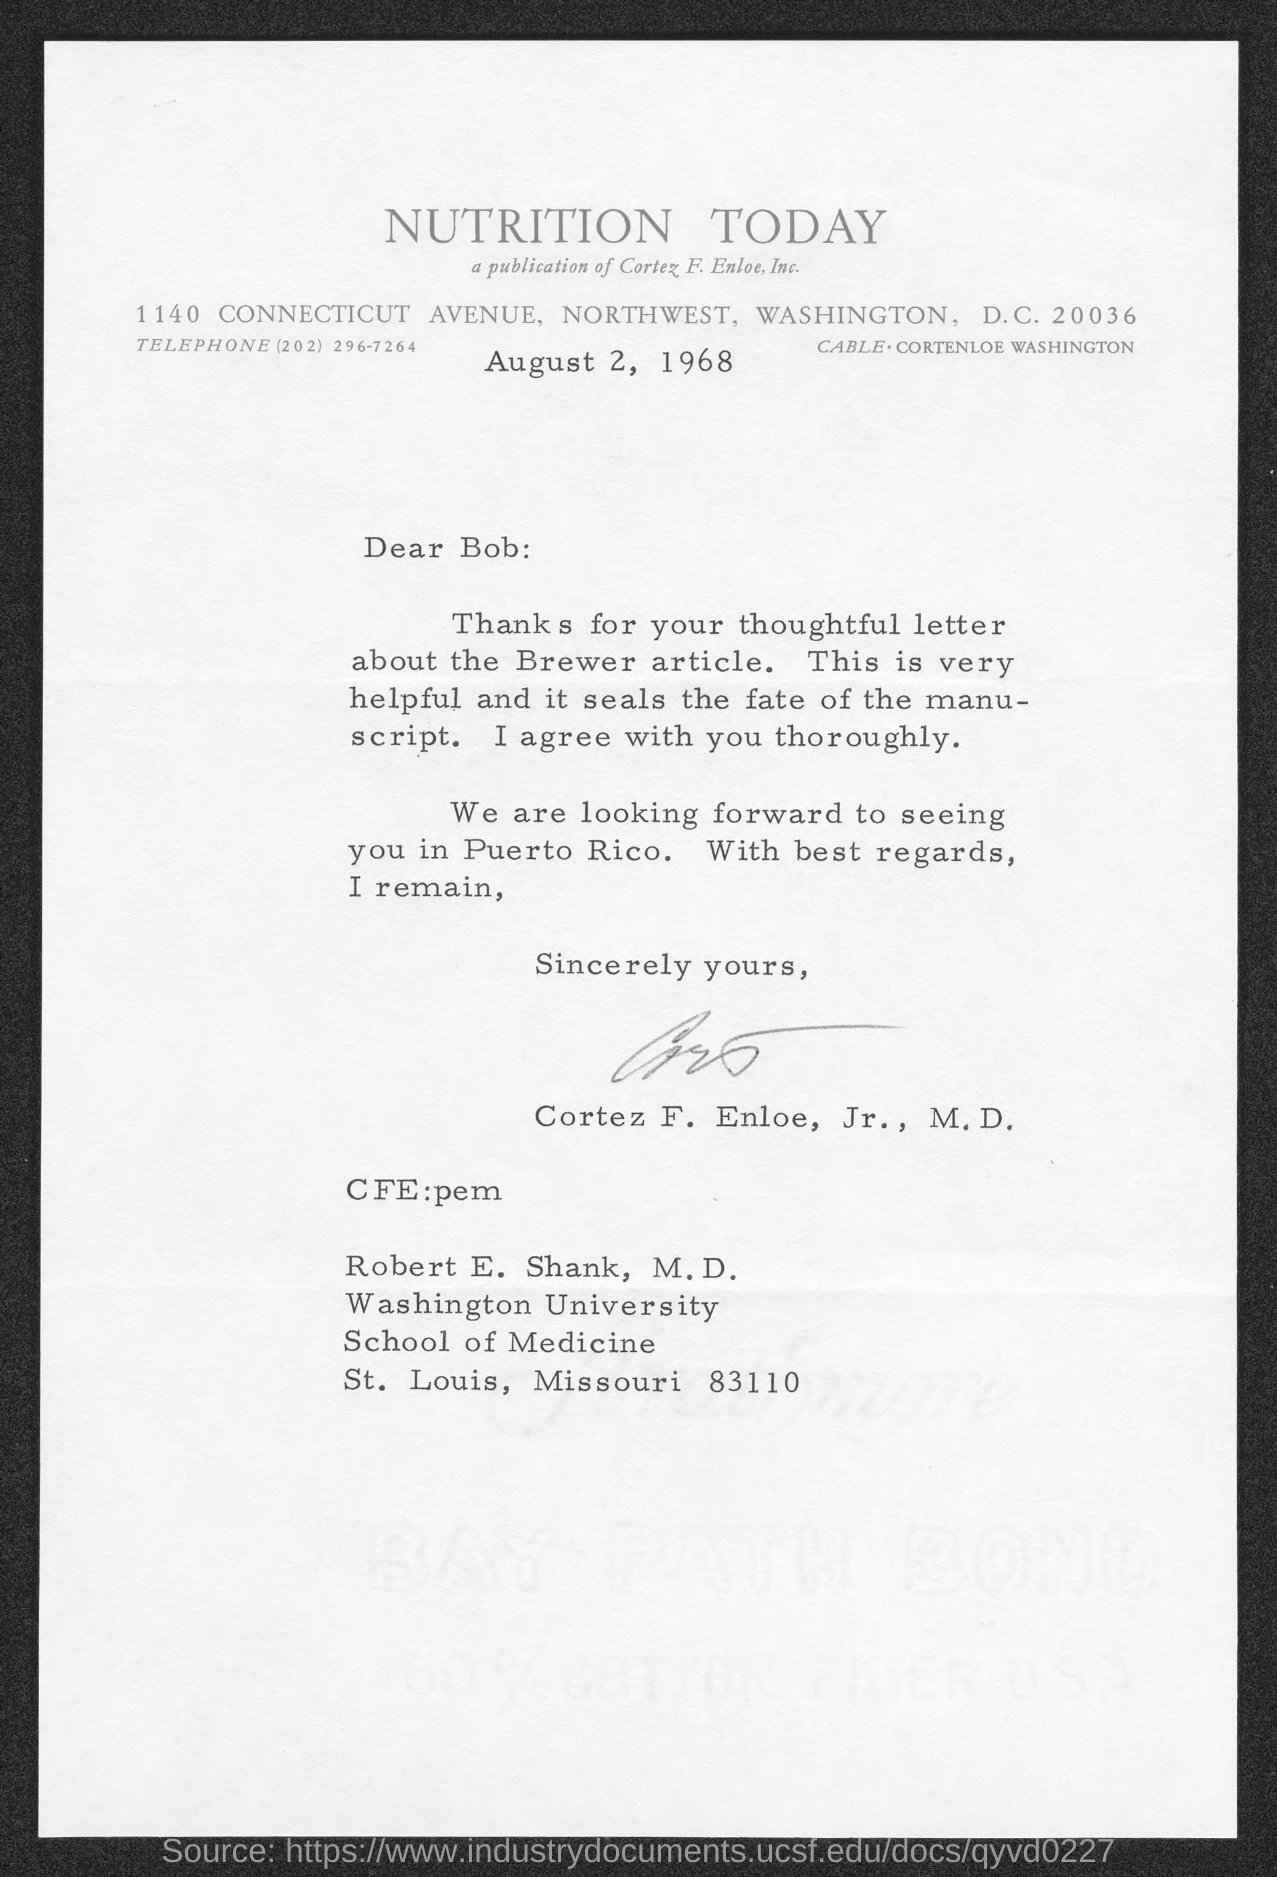What is the date on the document?
Your response must be concise. August 2, 1968. What was the thoughtful letter about?
Give a very brief answer. About the Brewer article. To Whom is this letter addressed to?
Give a very brief answer. Robert E. Shank, M.D. Who is this letter from?
Offer a terse response. Cortez F. Enloe, Jr., M.D. 